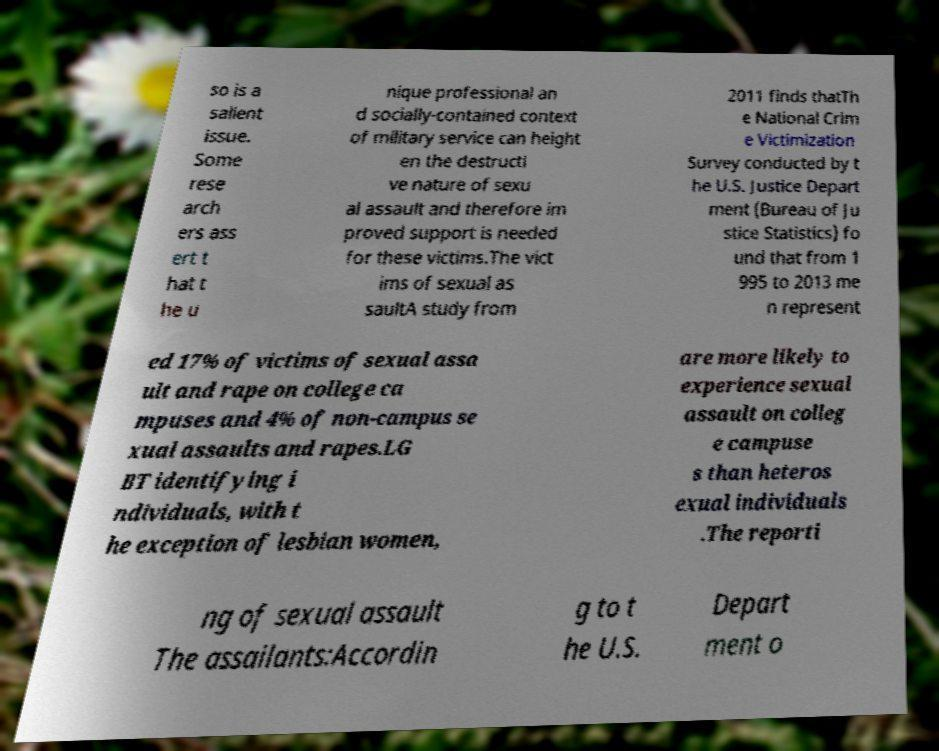Could you extract and type out the text from this image? so is a salient issue. Some rese arch ers ass ert t hat t he u nique professional an d socially-contained context of military service can height en the destructi ve nature of sexu al assault and therefore im proved support is needed for these victims.The vict ims of sexual as saultA study from 2011 finds thatTh e National Crim e Victimization Survey conducted by t he U.S. Justice Depart ment (Bureau of Ju stice Statistics) fo und that from 1 995 to 2013 me n represent ed 17% of victims of sexual assa ult and rape on college ca mpuses and 4% of non-campus se xual assaults and rapes.LG BT identifying i ndividuals, with t he exception of lesbian women, are more likely to experience sexual assault on colleg e campuse s than heteros exual individuals .The reporti ng of sexual assault The assailants:Accordin g to t he U.S. Depart ment o 